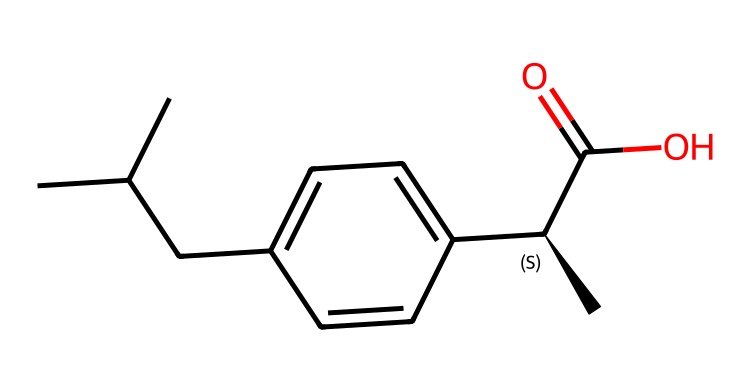What is the total number of carbon atoms in this molecule? Inspecting the SMILES representation, we can identify the 'C' characters, which represent carbon atoms. The molecule has a total of 13 carbon atoms.
Answer: 13 How many hydrogen atoms does this molecule contain? Counting the implicit hydrogens based on the tetravalency of carbon and visualizing the structure leads us to find that there are 18 hydrogen atoms in total.
Answer: 18 What functional group is present in ibuprofen? Analyzing the SMILES, the 'C(=O)O' segment indicates the presence of a carboxylic acid functional group, which is characteristic in ibuprofen.
Answer: carboxylic acid Does ibuprofen contain any double bonds? Looking at the SMILES, the 'C(=O)' indicates a double bond between carbon and oxygen, which is the carbonyl part of the carboxylic acid. Thus, yes, there is a double bond present.
Answer: yes What type of hydrocarbon is ibuprofen primarily classified as? The presence of a ring or branching and overall structure reveals that ibuprofen is classified primarily as an aromatic hydrocarbon due to the benzene component in its structure.
Answer: aromatic How many stereogenic centers are found in ibuprofen? The 'C@' in the SMILES notation indicates a chiral center; upon analyzing the structure, there is one stereogenic center in ibuprofen.
Answer: 1 What is the overall charge of ibuprofen? The molecule contains neutral atoms and is not indicated to have any charge-related components in the SMILES, thus it remains overall neutral.
Answer: neutral 